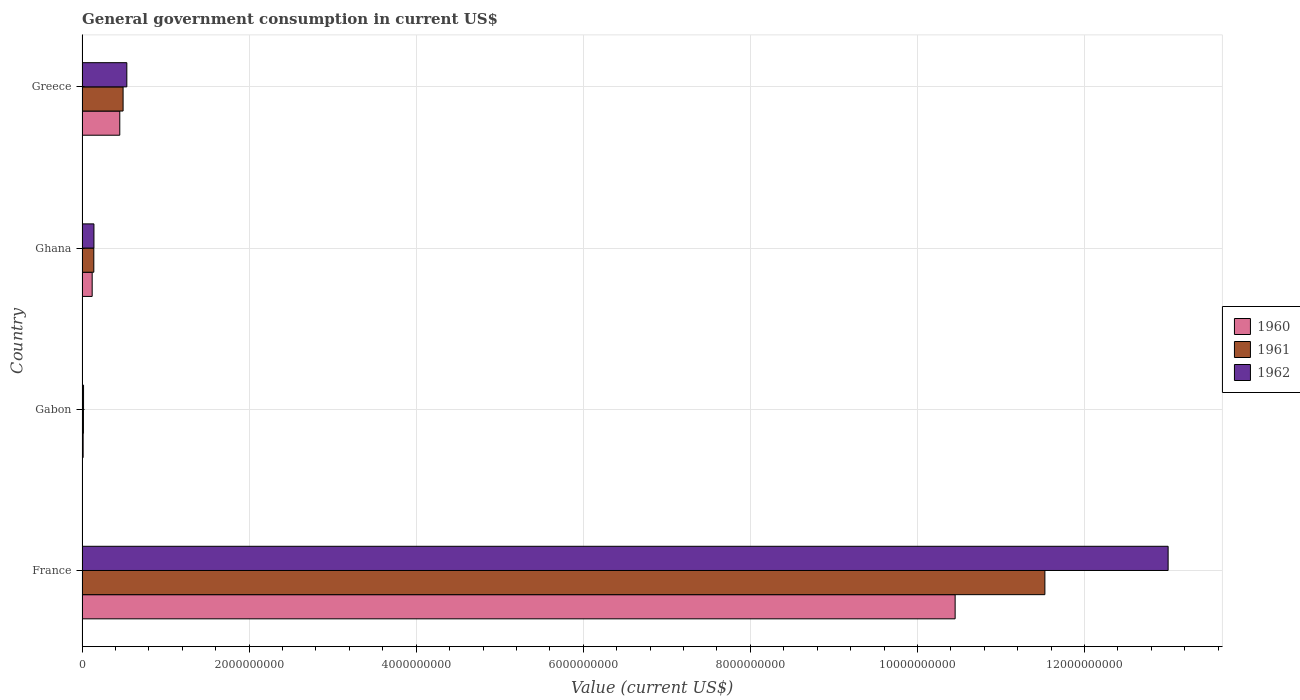How many different coloured bars are there?
Your answer should be compact. 3. How many groups of bars are there?
Offer a very short reply. 4. Are the number of bars per tick equal to the number of legend labels?
Your answer should be very brief. Yes. How many bars are there on the 3rd tick from the top?
Keep it short and to the point. 3. What is the label of the 3rd group of bars from the top?
Your answer should be very brief. Gabon. In how many cases, is the number of bars for a given country not equal to the number of legend labels?
Ensure brevity in your answer.  0. What is the government conusmption in 1960 in Greece?
Offer a terse response. 4.52e+08. Across all countries, what is the maximum government conusmption in 1962?
Ensure brevity in your answer.  1.30e+1. Across all countries, what is the minimum government conusmption in 1962?
Offer a terse response. 1.86e+07. In which country was the government conusmption in 1962 maximum?
Your answer should be compact. France. In which country was the government conusmption in 1960 minimum?
Provide a succinct answer. Gabon. What is the total government conusmption in 1960 in the graph?
Offer a very short reply. 1.10e+1. What is the difference between the government conusmption in 1960 in France and that in Gabon?
Offer a very short reply. 1.04e+1. What is the difference between the government conusmption in 1960 in Greece and the government conusmption in 1961 in Gabon?
Keep it short and to the point. 4.35e+08. What is the average government conusmption in 1960 per country?
Offer a very short reply. 2.76e+09. What is the difference between the government conusmption in 1962 and government conusmption in 1961 in Gabon?
Provide a succinct answer. 1.43e+06. What is the ratio of the government conusmption in 1961 in Gabon to that in Ghana?
Your response must be concise. 0.12. What is the difference between the highest and the second highest government conusmption in 1960?
Your answer should be very brief. 1.00e+1. What is the difference between the highest and the lowest government conusmption in 1960?
Your answer should be very brief. 1.04e+1. In how many countries, is the government conusmption in 1960 greater than the average government conusmption in 1960 taken over all countries?
Your response must be concise. 1. How many bars are there?
Provide a short and direct response. 12. How many countries are there in the graph?
Offer a terse response. 4. What is the difference between two consecutive major ticks on the X-axis?
Ensure brevity in your answer.  2.00e+09. How many legend labels are there?
Your response must be concise. 3. What is the title of the graph?
Ensure brevity in your answer.  General government consumption in current US$. What is the label or title of the X-axis?
Ensure brevity in your answer.  Value (current US$). What is the label or title of the Y-axis?
Offer a terse response. Country. What is the Value (current US$) of 1960 in France?
Provide a succinct answer. 1.05e+1. What is the Value (current US$) of 1961 in France?
Ensure brevity in your answer.  1.15e+1. What is the Value (current US$) in 1962 in France?
Your answer should be very brief. 1.30e+1. What is the Value (current US$) in 1960 in Gabon?
Offer a very short reply. 1.38e+07. What is the Value (current US$) of 1961 in Gabon?
Your answer should be compact. 1.72e+07. What is the Value (current US$) in 1962 in Gabon?
Provide a succinct answer. 1.86e+07. What is the Value (current US$) of 1960 in Ghana?
Offer a very short reply. 1.22e+08. What is the Value (current US$) of 1961 in Ghana?
Ensure brevity in your answer.  1.41e+08. What is the Value (current US$) in 1962 in Ghana?
Provide a short and direct response. 1.43e+08. What is the Value (current US$) in 1960 in Greece?
Provide a short and direct response. 4.52e+08. What is the Value (current US$) of 1961 in Greece?
Your response must be concise. 4.92e+08. What is the Value (current US$) of 1962 in Greece?
Your answer should be very brief. 5.37e+08. Across all countries, what is the maximum Value (current US$) in 1960?
Your answer should be very brief. 1.05e+1. Across all countries, what is the maximum Value (current US$) in 1961?
Offer a very short reply. 1.15e+1. Across all countries, what is the maximum Value (current US$) in 1962?
Ensure brevity in your answer.  1.30e+1. Across all countries, what is the minimum Value (current US$) in 1960?
Offer a very short reply. 1.38e+07. Across all countries, what is the minimum Value (current US$) in 1961?
Your answer should be compact. 1.72e+07. Across all countries, what is the minimum Value (current US$) in 1962?
Keep it short and to the point. 1.86e+07. What is the total Value (current US$) of 1960 in the graph?
Provide a short and direct response. 1.10e+1. What is the total Value (current US$) of 1961 in the graph?
Your response must be concise. 1.22e+1. What is the total Value (current US$) of 1962 in the graph?
Ensure brevity in your answer.  1.37e+1. What is the difference between the Value (current US$) of 1960 in France and that in Gabon?
Provide a succinct answer. 1.04e+1. What is the difference between the Value (current US$) of 1961 in France and that in Gabon?
Make the answer very short. 1.15e+1. What is the difference between the Value (current US$) of 1962 in France and that in Gabon?
Provide a short and direct response. 1.30e+1. What is the difference between the Value (current US$) of 1960 in France and that in Ghana?
Make the answer very short. 1.03e+1. What is the difference between the Value (current US$) in 1961 in France and that in Ghana?
Offer a terse response. 1.14e+1. What is the difference between the Value (current US$) of 1962 in France and that in Ghana?
Your response must be concise. 1.29e+1. What is the difference between the Value (current US$) of 1960 in France and that in Greece?
Offer a terse response. 1.00e+1. What is the difference between the Value (current US$) of 1961 in France and that in Greece?
Offer a terse response. 1.10e+1. What is the difference between the Value (current US$) of 1962 in France and that in Greece?
Ensure brevity in your answer.  1.25e+1. What is the difference between the Value (current US$) in 1960 in Gabon and that in Ghana?
Your response must be concise. -1.08e+08. What is the difference between the Value (current US$) of 1961 in Gabon and that in Ghana?
Offer a very short reply. -1.24e+08. What is the difference between the Value (current US$) in 1962 in Gabon and that in Ghana?
Ensure brevity in your answer.  -1.24e+08. What is the difference between the Value (current US$) in 1960 in Gabon and that in Greece?
Make the answer very short. -4.38e+08. What is the difference between the Value (current US$) in 1961 in Gabon and that in Greece?
Offer a terse response. -4.75e+08. What is the difference between the Value (current US$) in 1962 in Gabon and that in Greece?
Make the answer very short. -5.18e+08. What is the difference between the Value (current US$) of 1960 in Ghana and that in Greece?
Provide a short and direct response. -3.30e+08. What is the difference between the Value (current US$) in 1961 in Ghana and that in Greece?
Provide a short and direct response. -3.50e+08. What is the difference between the Value (current US$) of 1962 in Ghana and that in Greece?
Your answer should be compact. -3.94e+08. What is the difference between the Value (current US$) of 1960 in France and the Value (current US$) of 1961 in Gabon?
Provide a short and direct response. 1.04e+1. What is the difference between the Value (current US$) of 1960 in France and the Value (current US$) of 1962 in Gabon?
Keep it short and to the point. 1.04e+1. What is the difference between the Value (current US$) of 1961 in France and the Value (current US$) of 1962 in Gabon?
Provide a short and direct response. 1.15e+1. What is the difference between the Value (current US$) of 1960 in France and the Value (current US$) of 1961 in Ghana?
Your answer should be very brief. 1.03e+1. What is the difference between the Value (current US$) of 1960 in France and the Value (current US$) of 1962 in Ghana?
Offer a very short reply. 1.03e+1. What is the difference between the Value (current US$) in 1961 in France and the Value (current US$) in 1962 in Ghana?
Your answer should be very brief. 1.14e+1. What is the difference between the Value (current US$) in 1960 in France and the Value (current US$) in 1961 in Greece?
Provide a short and direct response. 9.96e+09. What is the difference between the Value (current US$) of 1960 in France and the Value (current US$) of 1962 in Greece?
Your answer should be compact. 9.92e+09. What is the difference between the Value (current US$) of 1961 in France and the Value (current US$) of 1962 in Greece?
Your answer should be very brief. 1.10e+1. What is the difference between the Value (current US$) of 1960 in Gabon and the Value (current US$) of 1961 in Ghana?
Offer a very short reply. -1.28e+08. What is the difference between the Value (current US$) in 1960 in Gabon and the Value (current US$) in 1962 in Ghana?
Make the answer very short. -1.29e+08. What is the difference between the Value (current US$) of 1961 in Gabon and the Value (current US$) of 1962 in Ghana?
Ensure brevity in your answer.  -1.26e+08. What is the difference between the Value (current US$) of 1960 in Gabon and the Value (current US$) of 1961 in Greece?
Provide a short and direct response. -4.78e+08. What is the difference between the Value (current US$) in 1960 in Gabon and the Value (current US$) in 1962 in Greece?
Give a very brief answer. -5.23e+08. What is the difference between the Value (current US$) in 1961 in Gabon and the Value (current US$) in 1962 in Greece?
Your answer should be very brief. -5.19e+08. What is the difference between the Value (current US$) of 1960 in Ghana and the Value (current US$) of 1961 in Greece?
Offer a very short reply. -3.70e+08. What is the difference between the Value (current US$) of 1960 in Ghana and the Value (current US$) of 1962 in Greece?
Your response must be concise. -4.15e+08. What is the difference between the Value (current US$) of 1961 in Ghana and the Value (current US$) of 1962 in Greece?
Offer a terse response. -3.95e+08. What is the average Value (current US$) of 1960 per country?
Ensure brevity in your answer.  2.76e+09. What is the average Value (current US$) of 1961 per country?
Your answer should be very brief. 3.04e+09. What is the average Value (current US$) of 1962 per country?
Ensure brevity in your answer.  3.42e+09. What is the difference between the Value (current US$) in 1960 and Value (current US$) in 1961 in France?
Make the answer very short. -1.07e+09. What is the difference between the Value (current US$) of 1960 and Value (current US$) of 1962 in France?
Ensure brevity in your answer.  -2.55e+09. What is the difference between the Value (current US$) of 1961 and Value (current US$) of 1962 in France?
Keep it short and to the point. -1.48e+09. What is the difference between the Value (current US$) in 1960 and Value (current US$) in 1961 in Gabon?
Ensure brevity in your answer.  -3.38e+06. What is the difference between the Value (current US$) in 1960 and Value (current US$) in 1962 in Gabon?
Offer a very short reply. -4.81e+06. What is the difference between the Value (current US$) in 1961 and Value (current US$) in 1962 in Gabon?
Give a very brief answer. -1.43e+06. What is the difference between the Value (current US$) of 1960 and Value (current US$) of 1961 in Ghana?
Offer a terse response. -1.96e+07. What is the difference between the Value (current US$) in 1960 and Value (current US$) in 1962 in Ghana?
Your answer should be very brief. -2.10e+07. What is the difference between the Value (current US$) in 1961 and Value (current US$) in 1962 in Ghana?
Make the answer very short. -1.40e+06. What is the difference between the Value (current US$) of 1960 and Value (current US$) of 1961 in Greece?
Offer a terse response. -3.96e+07. What is the difference between the Value (current US$) in 1960 and Value (current US$) in 1962 in Greece?
Make the answer very short. -8.43e+07. What is the difference between the Value (current US$) in 1961 and Value (current US$) in 1962 in Greece?
Your answer should be very brief. -4.47e+07. What is the ratio of the Value (current US$) in 1960 in France to that in Gabon?
Keep it short and to the point. 755.44. What is the ratio of the Value (current US$) in 1961 in France to that in Gabon?
Offer a very short reply. 669.38. What is the ratio of the Value (current US$) of 1962 in France to that in Gabon?
Offer a very short reply. 697.15. What is the ratio of the Value (current US$) in 1960 in France to that in Ghana?
Your answer should be compact. 85.77. What is the ratio of the Value (current US$) in 1961 in France to that in Ghana?
Your response must be concise. 81.47. What is the ratio of the Value (current US$) in 1962 in France to that in Ghana?
Offer a very short reply. 91. What is the ratio of the Value (current US$) of 1960 in France to that in Greece?
Ensure brevity in your answer.  23.11. What is the ratio of the Value (current US$) of 1961 in France to that in Greece?
Your response must be concise. 23.43. What is the ratio of the Value (current US$) in 1962 in France to that in Greece?
Make the answer very short. 24.23. What is the ratio of the Value (current US$) of 1960 in Gabon to that in Ghana?
Provide a succinct answer. 0.11. What is the ratio of the Value (current US$) in 1961 in Gabon to that in Ghana?
Provide a short and direct response. 0.12. What is the ratio of the Value (current US$) of 1962 in Gabon to that in Ghana?
Keep it short and to the point. 0.13. What is the ratio of the Value (current US$) of 1960 in Gabon to that in Greece?
Give a very brief answer. 0.03. What is the ratio of the Value (current US$) in 1961 in Gabon to that in Greece?
Offer a very short reply. 0.04. What is the ratio of the Value (current US$) of 1962 in Gabon to that in Greece?
Keep it short and to the point. 0.03. What is the ratio of the Value (current US$) of 1960 in Ghana to that in Greece?
Your answer should be compact. 0.27. What is the ratio of the Value (current US$) of 1961 in Ghana to that in Greece?
Your answer should be compact. 0.29. What is the ratio of the Value (current US$) in 1962 in Ghana to that in Greece?
Your answer should be very brief. 0.27. What is the difference between the highest and the second highest Value (current US$) of 1960?
Your answer should be compact. 1.00e+1. What is the difference between the highest and the second highest Value (current US$) of 1961?
Offer a very short reply. 1.10e+1. What is the difference between the highest and the second highest Value (current US$) of 1962?
Give a very brief answer. 1.25e+1. What is the difference between the highest and the lowest Value (current US$) of 1960?
Offer a very short reply. 1.04e+1. What is the difference between the highest and the lowest Value (current US$) of 1961?
Your answer should be compact. 1.15e+1. What is the difference between the highest and the lowest Value (current US$) of 1962?
Your answer should be compact. 1.30e+1. 